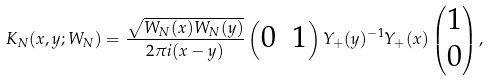<formula> <loc_0><loc_0><loc_500><loc_500>K _ { N } ( x , y ; W _ { N } ) = \frac { \sqrt { W _ { N } ( x ) W _ { N } ( y ) } } { 2 \pi i ( x - y ) } \begin{pmatrix} 0 & 1 \end{pmatrix} Y _ { + } ( y ) ^ { - 1 } Y _ { + } ( x ) \begin{pmatrix} 1 \\ 0 \end{pmatrix} ,</formula> 